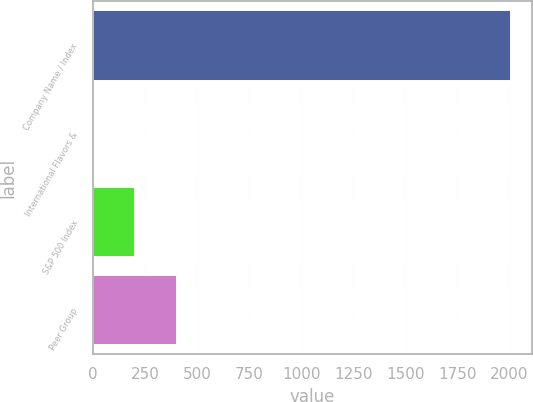Convert chart to OTSL. <chart><loc_0><loc_0><loc_500><loc_500><bar_chart><fcel>Company Name / Index<fcel>International Flavors &<fcel>S&P 500 Index<fcel>Peer Group<nl><fcel>2007<fcel>0.36<fcel>201.02<fcel>401.68<nl></chart> 